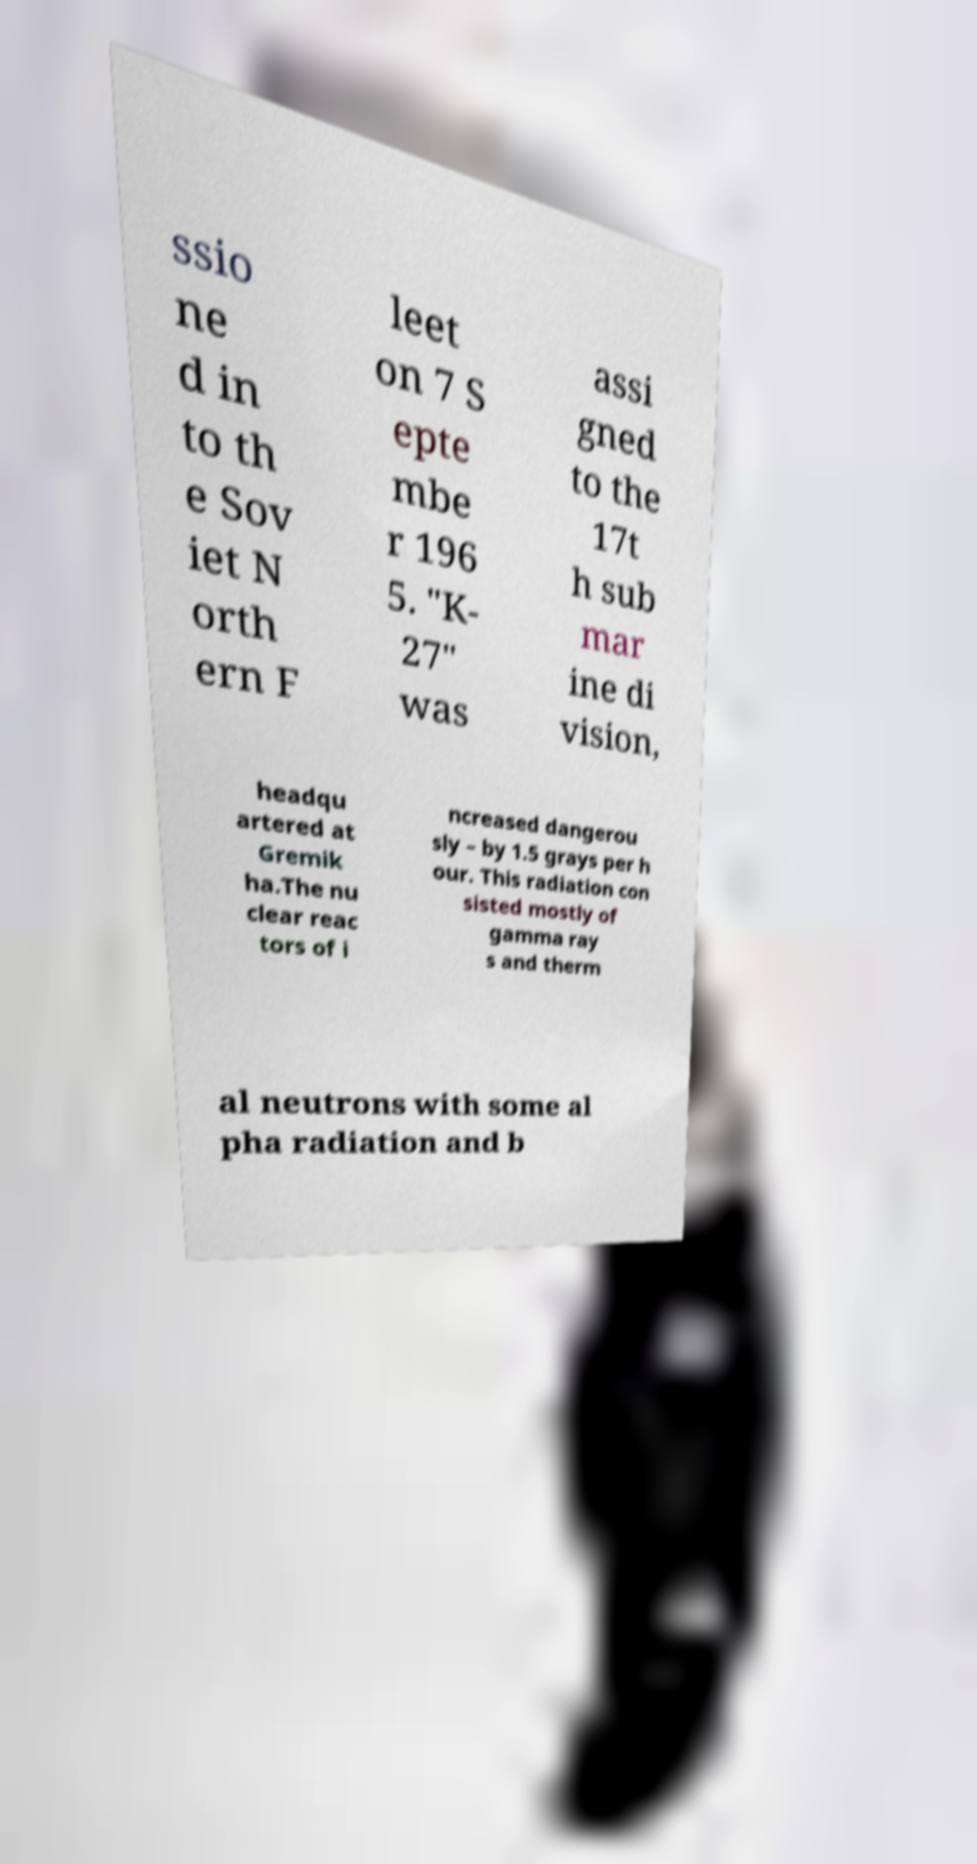What messages or text are displayed in this image? I need them in a readable, typed format. ssio ne d in to th e Sov iet N orth ern F leet on 7 S epte mbe r 196 5. "K- 27" was assi gned to the 17t h sub mar ine di vision, headqu artered at Gremik ha.The nu clear reac tors of i ncreased dangerou sly – by 1.5 grays per h our. This radiation con sisted mostly of gamma ray s and therm al neutrons with some al pha radiation and b 